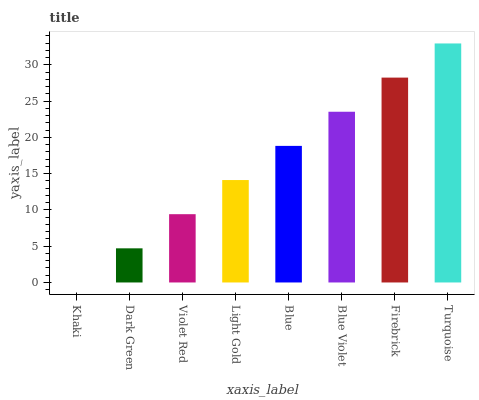Is Khaki the minimum?
Answer yes or no. Yes. Is Turquoise the maximum?
Answer yes or no. Yes. Is Dark Green the minimum?
Answer yes or no. No. Is Dark Green the maximum?
Answer yes or no. No. Is Dark Green greater than Khaki?
Answer yes or no. Yes. Is Khaki less than Dark Green?
Answer yes or no. Yes. Is Khaki greater than Dark Green?
Answer yes or no. No. Is Dark Green less than Khaki?
Answer yes or no. No. Is Blue the high median?
Answer yes or no. Yes. Is Light Gold the low median?
Answer yes or no. Yes. Is Light Gold the high median?
Answer yes or no. No. Is Khaki the low median?
Answer yes or no. No. 